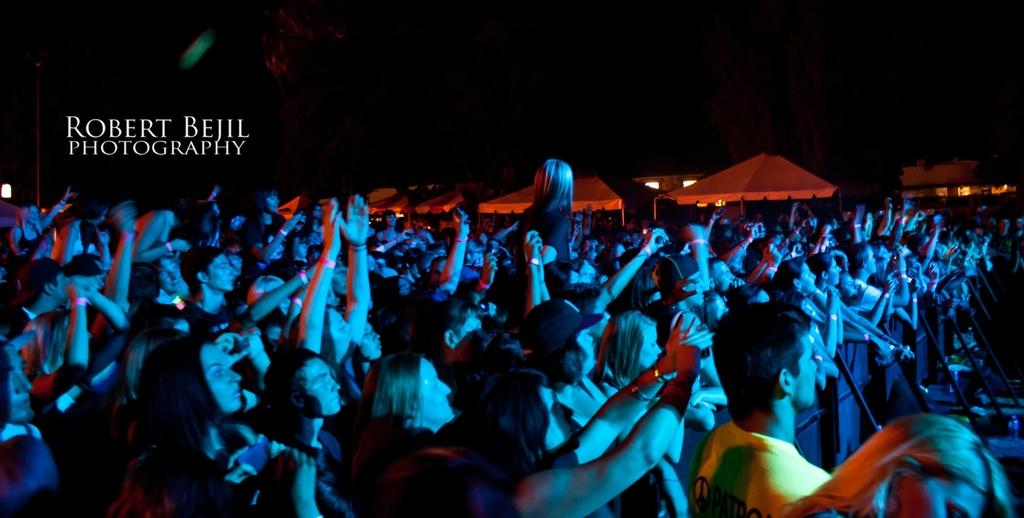What is the main subject of the image? The main subject of the image is a crowd. What can be seen in the background of the image? There are tents in the background of the image. Where is the writing located in the image? The writing is on the left side of the image. How would you describe the lighting in the image? The background of the image is dark. What type of spark can be seen in the image? There is no spark present in the image. How does the behavior of the crowd change throughout the image? The image does not depict any changes in the crowd's behavior over time. 